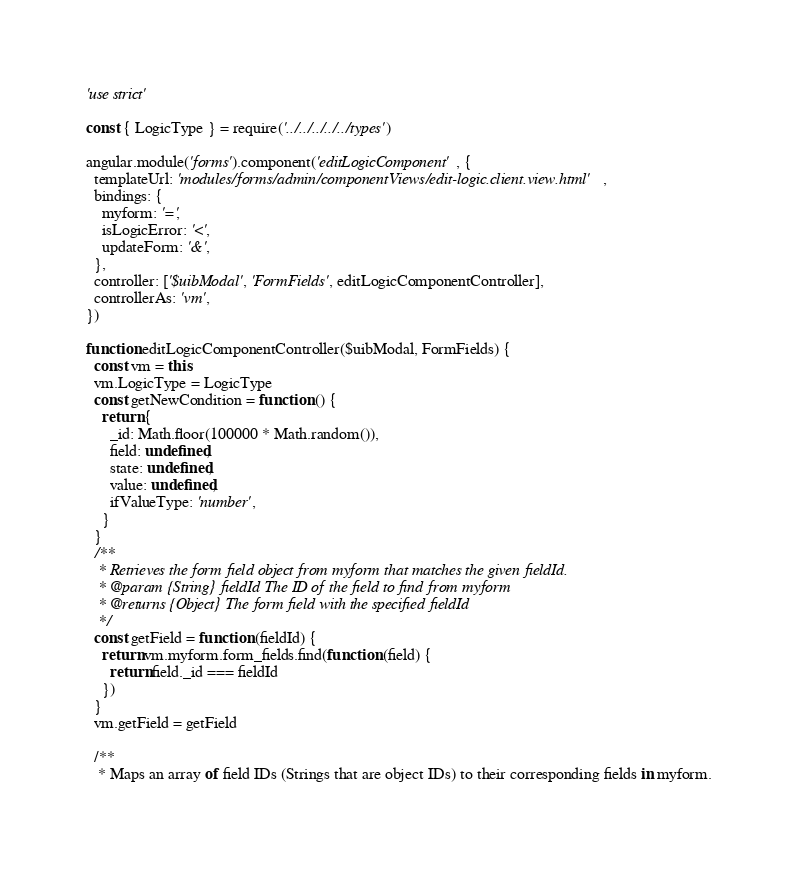<code> <loc_0><loc_0><loc_500><loc_500><_JavaScript_>'use strict'

const { LogicType } = require('../../../../../types')

angular.module('forms').component('editLogicComponent', {
  templateUrl: 'modules/forms/admin/componentViews/edit-logic.client.view.html',
  bindings: {
    myform: '=',
    isLogicError: '<',
    updateForm: '&',
  },
  controller: ['$uibModal', 'FormFields', editLogicComponentController],
  controllerAs: 'vm',
})

function editLogicComponentController($uibModal, FormFields) {
  const vm = this
  vm.LogicType = LogicType
  const getNewCondition = function () {
    return {
      _id: Math.floor(100000 * Math.random()),
      field: undefined,
      state: undefined,
      value: undefined,
      ifValueType: 'number',
    }
  }
  /**
   * Retrieves the form field object from myform that matches the given fieldId.
   * @param {String} fieldId The ID of the field to find from myform
   * @returns {Object} The form field with the specified fieldId
   */
  const getField = function (fieldId) {
    return vm.myform.form_fields.find(function (field) {
      return field._id === fieldId
    })
  }
  vm.getField = getField

  /**
   * Maps an array of field IDs (Strings that are object IDs) to their corresponding fields in myform.</code> 